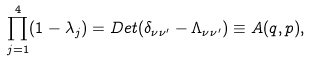<formula> <loc_0><loc_0><loc_500><loc_500>\prod _ { j = 1 } ^ { 4 } ( 1 - \lambda _ { j } ) = D e t ( \delta _ { \nu \nu ^ { \prime } } - \Lambda _ { \nu \nu ^ { \prime } } ) \equiv A ( q , p ) ,</formula> 